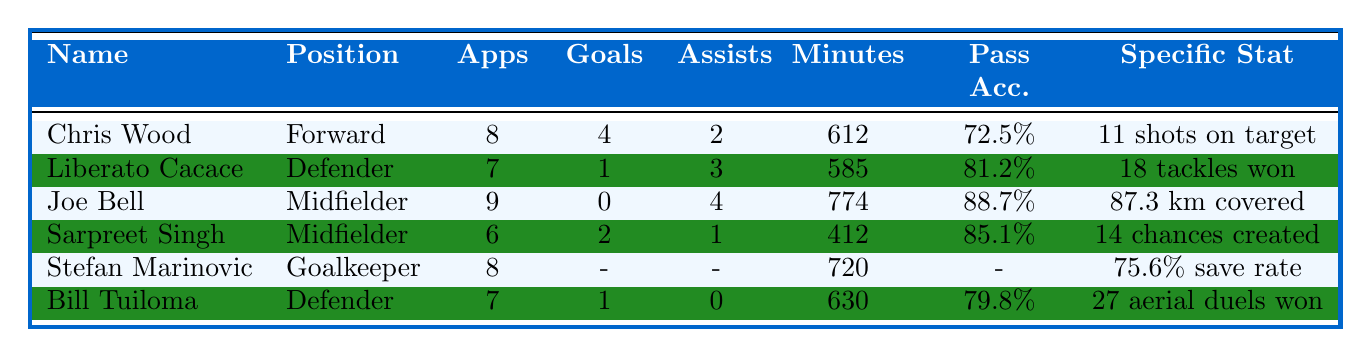What is the total number of goals scored by New Zealand players in 2022? To find the total number of goals, add the goals scored by each player: Chris Wood (4) + Liberato Cacace (1) + Joe Bell (0) + Sarpreet Singh (2) + Stefan Marinovic (0) + Bill Tuiloma (1) = 8.
Answer: 8 Which player had the highest number of assists? Looking at the assists for each player, Joe Bell (4) has the highest assists, followed by Liberato Cacace (3) and Chris Wood (2).
Answer: Joe Bell What is the average pass accuracy of the players listed? Calculate the average pass accuracy by adding each player's pass accuracy: (72.5 + 81.2 + 88.7 + 85.1 + 75.6 + 79.8) = 483.8. Divide by the number of players (6) to find the average: 483.8 / 6 = 80.63.
Answer: 80.63% Did Sarpreet Singh create more chances than he scored goals? Sarpreet Singh has created 14 chances and scored 2 goals, which is more.
Answer: Yes Which player had the highest minutes played among midfielders? Compare the minutes played by the midfielders: Joe Bell (774) and Sarpreet Singh (412). Joe Bell has played more minutes than Sarpreet Singh.
Answer: Joe Bell How many players scored more than 1 goal? The only player who scored more than 1 goal is Chris Wood (4). So, there is 1 player who meets that criterion.
Answer: 1 What is the save percentage of the goalkeeper, Stefan Marinovic? Stefan Marinovic's save percentage is provided as 75.6%.
Answer: 75.6% How many assists did Liberato Cacace and Bill Tuiloma contribute together? Add the assists of both players: Liberato Cacace (3) + Bill Tuiloma (0) = 3 assists combined.
Answer: 3 Which player had the lowest pass accuracy? Among the players, Chris Wood has the lowest pass accuracy at 72.5%.
Answer: Chris Wood What is the difference in goals scored between Chris Wood and Sarpreet Singh? Chris Wood scored 4 goals and Sarpreet Singh scored 2. The difference is 4 - 2 = 2 goals.
Answer: 2 How many tackles did Liberato Cacace win compared to Bill Tuiloma's clearances? Liberato Cacace won 18 tackles and Bill Tuiloma had 34 clearances. The comparison shows that Bill Tuiloma had more clearances than Liberato had tackles.
Answer: No, Bill Tuiloma had more clearances 